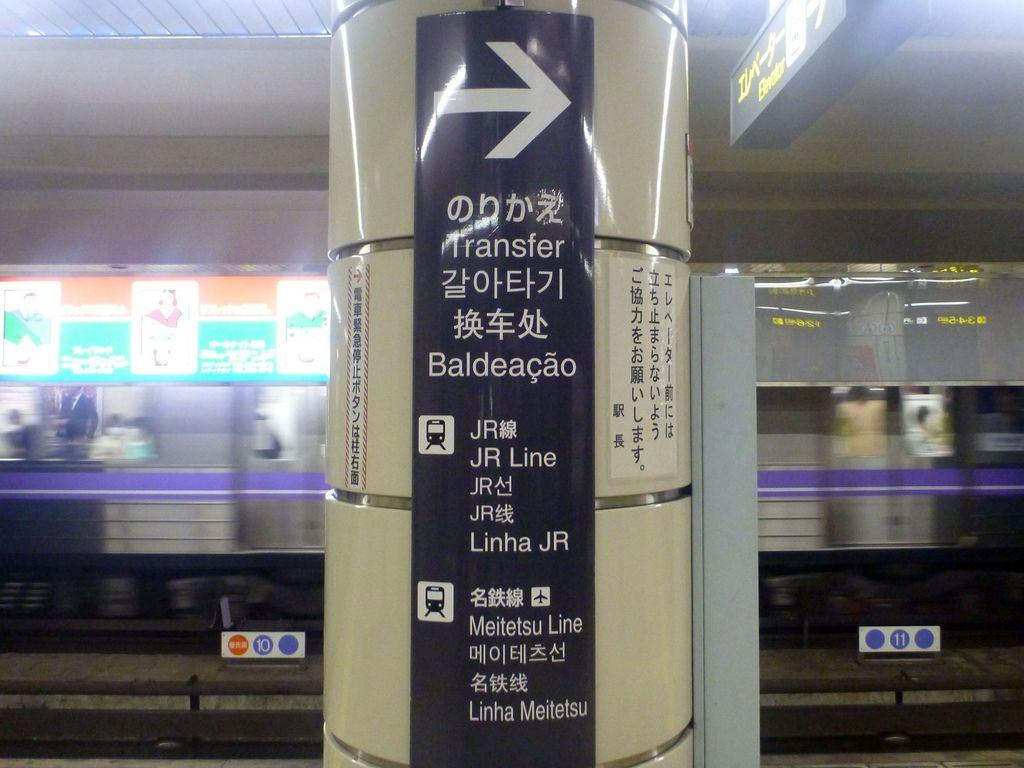Provide a one-sentence caption for the provided image. A black sign pointing right with several languages under it. 